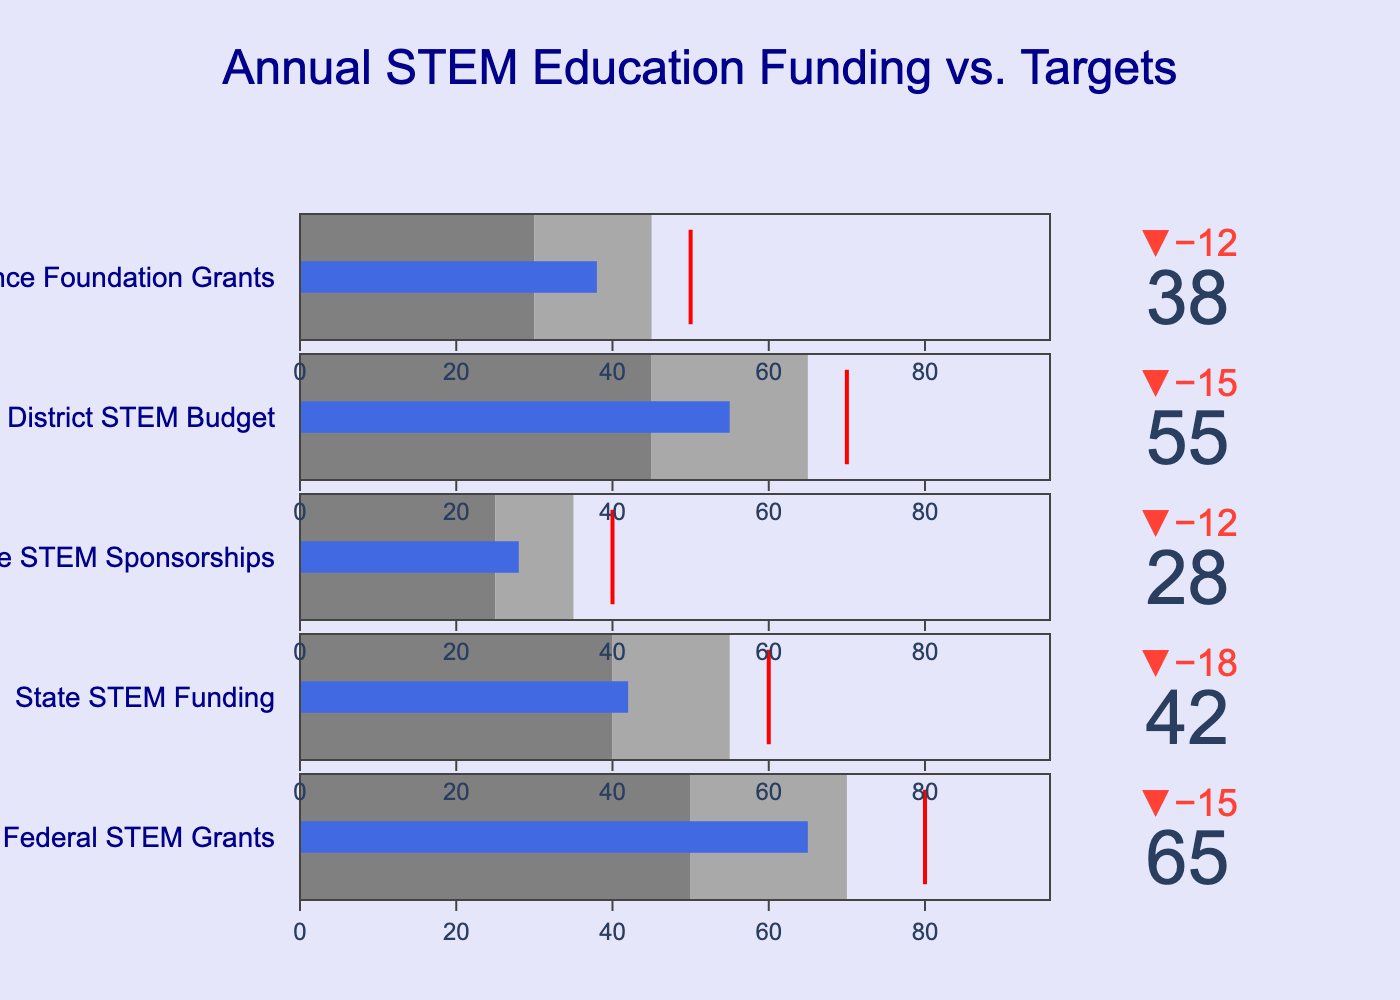What's the title of the chart? The title is located at the top center of the chart, which clearly states the main subject of the visualization for quick identification.
Answer: Annual STEM Education Funding vs. Targets What category has the highest actual funding? By examining the values represented by the bars, we can see which one is the tallest.
Answer: Federal STEM Grants How much more funding does the Federal STEM Grants need to meet its target? The target is 80, and the actual is 65. The difference between the two is 80 - 65.
Answer: 15 How many categories achieve the "Good" funding level? "Good" funding levels are indicated by the specified range. We need to count the instances where the actual funding surpasses the lower bound of this range.
Answer: 1 (Federal STEM Grants) Which category is the farthest from reaching its target? Comparing the deltas (differences) between actual and target values across all categories, the largest delta indicates the greatest shortfall.
Answer: Corporate STEM Sponsorships Which categories fall into the Poor funding level? Poor funding levels are shown in the light gray section at the lower end. Compare actual funding to determine if it falls within the "Poor" range for each category.
Answer: Corporate STEM Sponsorships Compare the actual funding of State STEM Funding and School District STEM Budget. Which category received more? The actual funding for each category can be directly compared by looking at the heights of the corresponding bars.
Answer: School District STEM Budget What's the average target funding for all categories? Add all target values together and then divide by the number of categories to find the mean. (80 + 60 + 40 + 70 + 50) / 5 = 300 / 5
Answer: 60 Does any category exceed its target funding? Examine if any actual value goes beyond its respective target, indicated by bars surpassing the thresholds.
Answer: No What is the funding shortfall for National Science Foundation Grants? Compare its actual funding with its target and calculate the difference: 50 - 38.
Answer: 12 